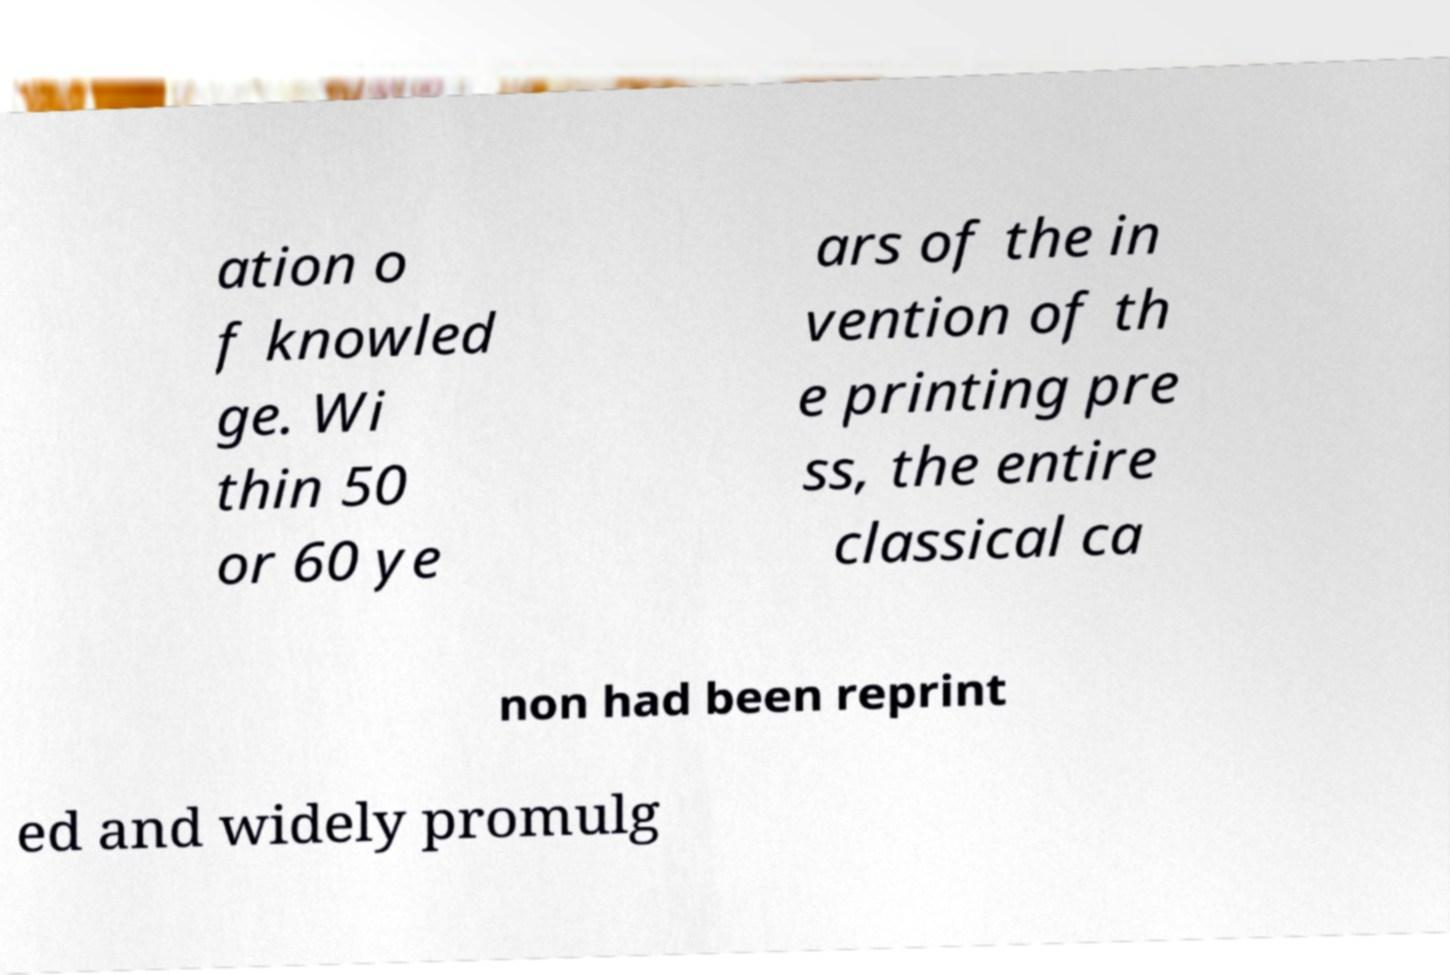For documentation purposes, I need the text within this image transcribed. Could you provide that? ation o f knowled ge. Wi thin 50 or 60 ye ars of the in vention of th e printing pre ss, the entire classical ca non had been reprint ed and widely promulg 